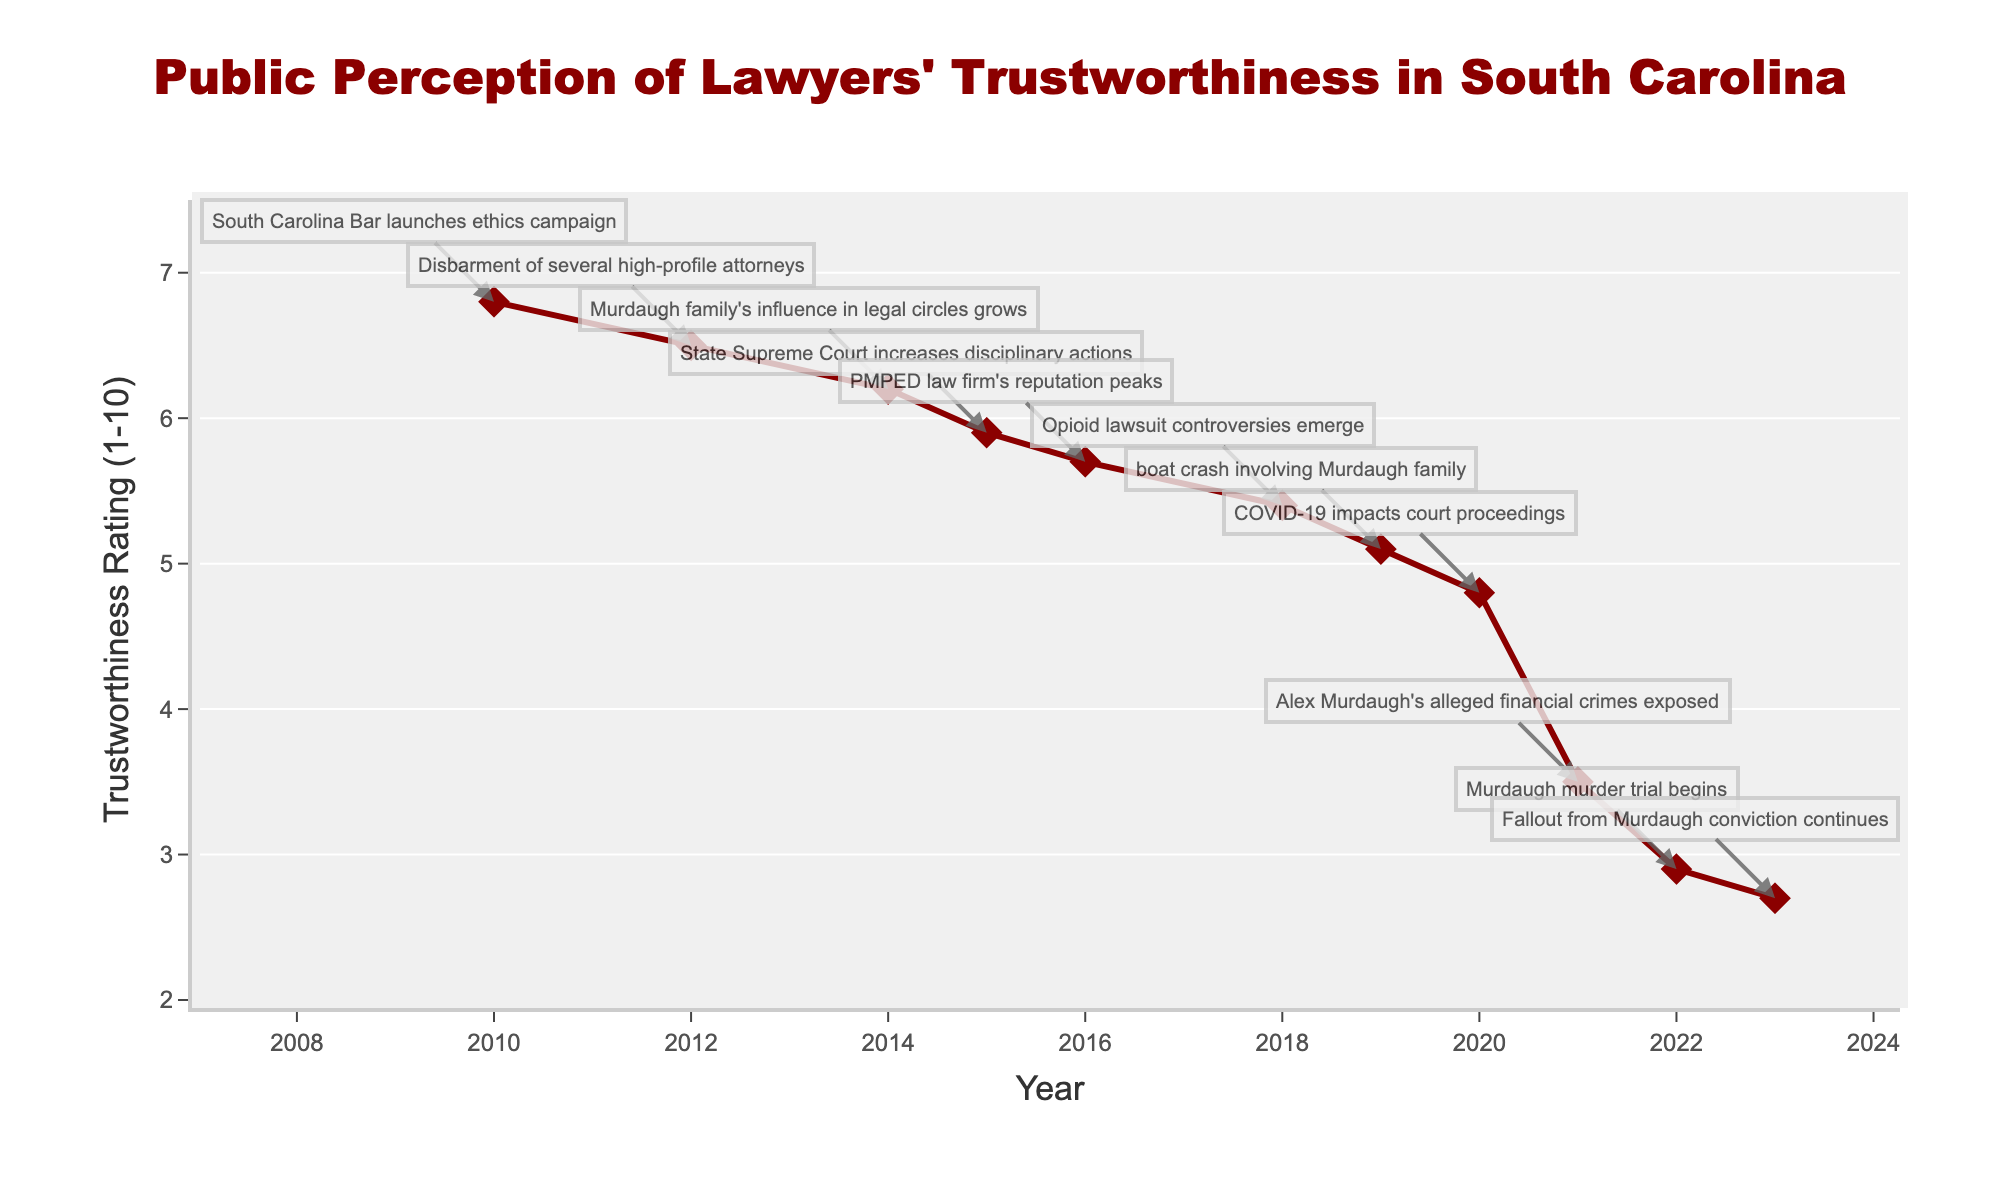what was the trustworthiness rating in 2012? To find the trustworthiness rating in 2012, refer to the data point corresponding to the year 2012 in the line chart.
Answer: 6.5 Between which years did the trustworthiness rating drop the most significantly? Identify the time gap with the largest decline in the trustworthiness rating by comparing the ratings year-by-year. The most notable drop is between 2020 and 2021.
Answer: 2020 to 2021 What notable event occurred in the year when the trustworthiness rating was the highest on the plot? Look for the peak trustworthiness rating, which is in 2010, then refer to the notable event for that year from the annotations.
Answer: South Carolina Bar launches ethics campaign What is the difference in trustworthiness rating between 2010 and 2023? Subtract the trustworthiness rating of 2023 from that of 2010 referring to the figure.
Answer: 4.1 Over how many years did the trustworthiness rating consistently decline from 2010 onwards? Identify the continuous sequence of years where the trustworthiness rating consistently drops without an increase. It starts from 2010 and goes until 2023.
Answer: 13 years Which year saw the lowest trustworthiness rating and what event was associated with that year? Locate the lowest point on the trustworthiness rating line and note the corresponding year and event.
Answer: 2023, Fallout from Murdaugh conviction continues How much did the trustworthiness rating decline between 2015 and 2021? Subtract the trustworthiness rating in 2021 from that in 2015 referring to the figure.
Answer: 2.4 Compare the trustworthiness rating in 2014 and 2016. Which year had a higher rating? Check the ratings for 2014 and 2016 and see which one is higher.
Answer: 2014 What visual attribute is used to indicate notable events on the plot? Look at the graphical elements that highlight notable events; these are usually annotations with arrows pointing to the relevant data points.
Answer: Annotations with arrows Between which two consecutive years did the trustworthiness rating change the least? Analyze the year-to-year changes in trustworthiness rating and identify the two consecutive years with the smallest change.
Answer: 2022 to 2023 